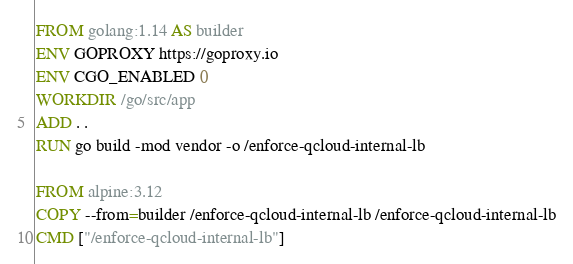Convert code to text. <code><loc_0><loc_0><loc_500><loc_500><_Dockerfile_>FROM golang:1.14 AS builder
ENV GOPROXY https://goproxy.io
ENV CGO_ENABLED 0
WORKDIR /go/src/app
ADD . .
RUN go build -mod vendor -o /enforce-qcloud-internal-lb

FROM alpine:3.12
COPY --from=builder /enforce-qcloud-internal-lb /enforce-qcloud-internal-lb
CMD ["/enforce-qcloud-internal-lb"]</code> 